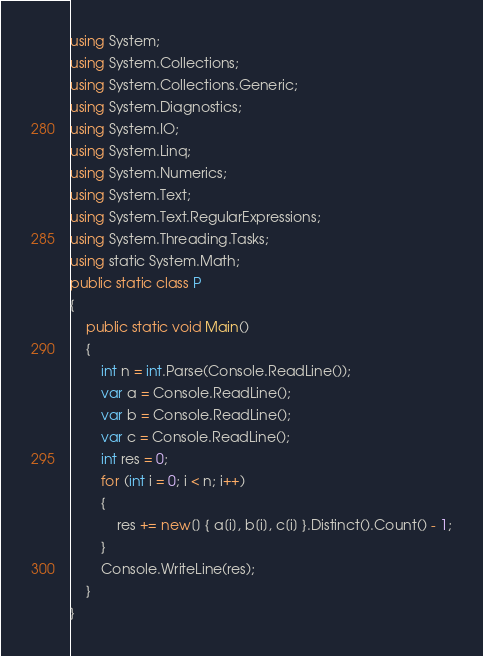Convert code to text. <code><loc_0><loc_0><loc_500><loc_500><_C#_>using System;
using System.Collections;
using System.Collections.Generic;
using System.Diagnostics;
using System.IO;
using System.Linq;
using System.Numerics;
using System.Text;
using System.Text.RegularExpressions;
using System.Threading.Tasks;
using static System.Math;
public static class P
{
    public static void Main()
    {
        int n = int.Parse(Console.ReadLine());
        var a = Console.ReadLine();
        var b = Console.ReadLine();
        var c = Console.ReadLine();
        int res = 0;
        for (int i = 0; i < n; i++)
        {
            res += new[] { a[i], b[i], c[i] }.Distinct().Count() - 1;
        }
        Console.WriteLine(res);
    }
}</code> 